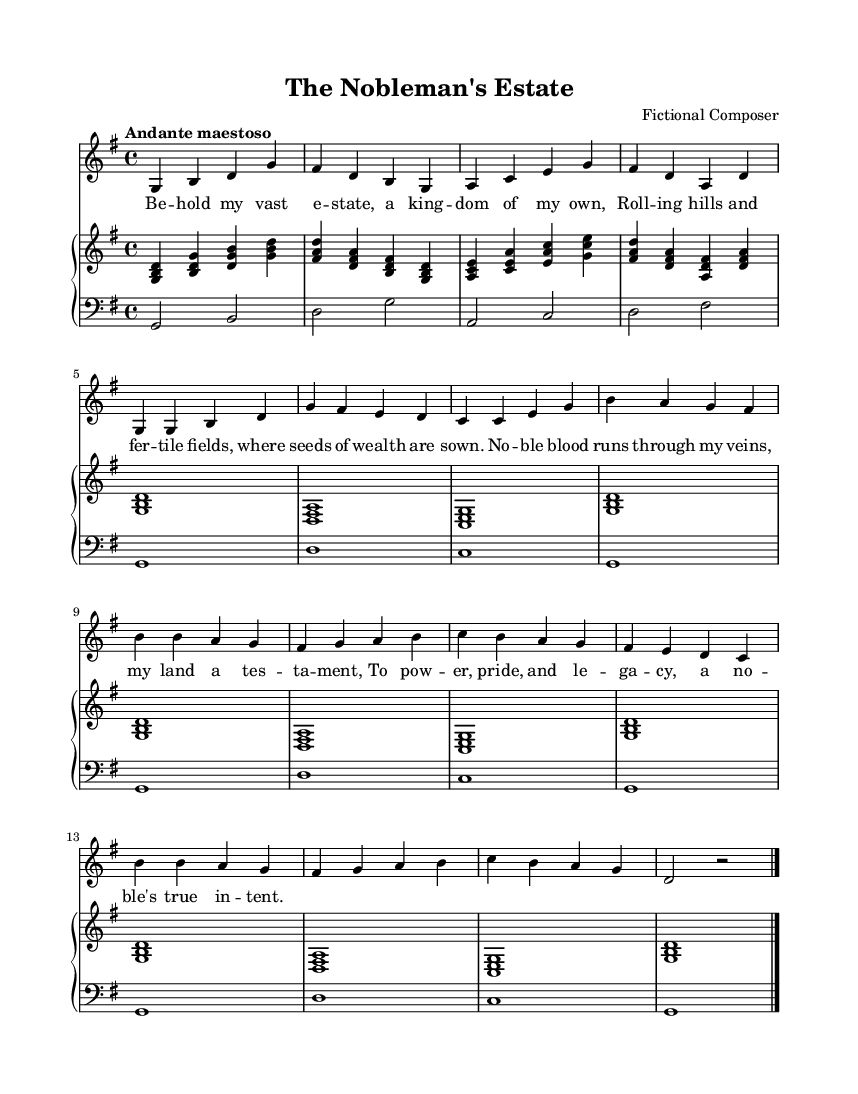What is the tempo marking of this piece? The tempo marking indicates "Andante maestoso," which suggests a moderately slow and majestic tempo. This can be found prominently at the beginning of the sheet music.
Answer: Andante maestoso What is the time signature of this music? The time signature is 4/4, which is noted at the beginning of the score. This means there are four beats in each measure, and each beat is a quarter note.
Answer: 4/4 What key is the piece written in? The piece is in G major, indicated by the key signature containing one sharp (F#) at the beginning of the score, confirming its major tonality.
Answer: G major How many measures are there in the melody? By counting all the measures in the melody part, we find there are 12 measures in total, as indicated by the four-bar sections.
Answer: 12 What are the lyrics of the refrain? The lyrics of the refrain are: "No -- ble blood runs through my veins, my land a tes -- ta -- ment, To pow -- er, pride, and le -- ga -- cy, a no -- ble's true in -- tent." Each line is clearly marked in the lyrics section corresponding to the music.
Answer: No -- ble blood runs through my veins, my land a tes -- ta -- ment, To pow -- er, pride, and le -- ga -- cy, a no -- ble's true in -- tent Which instrument is the primary voice in this score? The primary voice in this score is labeled as "voice" in the staff, indicating that this part is intended for singing or vocal performance, while the piano staff supports it.
Answer: Voice 